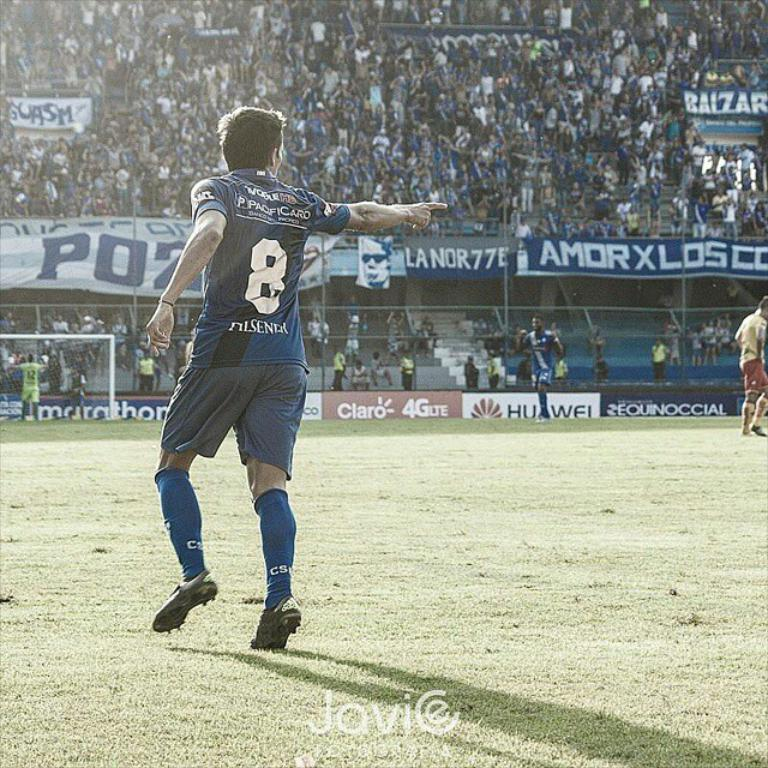<image>
Describe the image concisely. player 8 ion the field in front of a huawei banner 